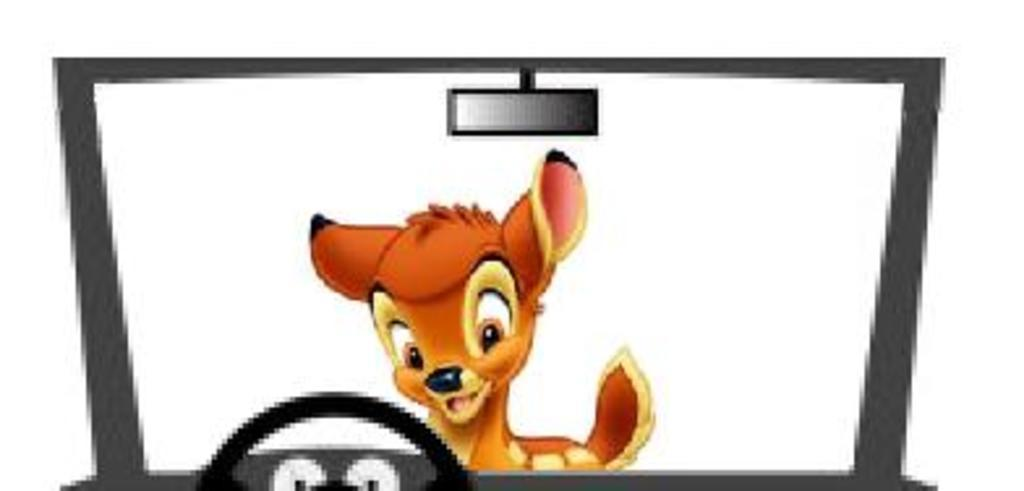What type of image is being described? The image is an animated picture. What animal can be seen in the image? There is a deer in the image. What other object is present in the image? There is a vehicle in the image. How many crates are being carried by the deer in the image? There are no crates present in the image; it features a deer and a vehicle. How far apart are the deer and the vehicle in the image? The image is animated, so it is not possible to determine the distance between the deer and the vehicle based on the provided facts. 